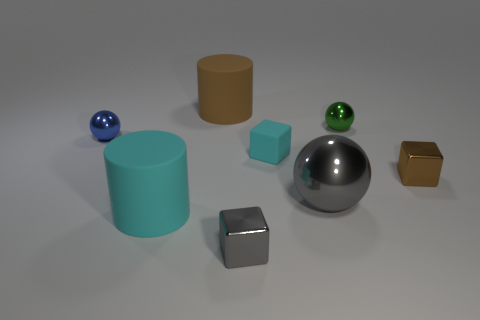Subtract all tiny metallic spheres. How many spheres are left? 1 Add 1 tiny green cubes. How many objects exist? 9 Subtract 1 balls. How many balls are left? 2 Subtract all cubes. How many objects are left? 5 Add 3 small blue objects. How many small blue objects exist? 4 Subtract 1 cyan cylinders. How many objects are left? 7 Subtract all blue cubes. Subtract all red balls. How many cubes are left? 3 Subtract all purple balls. Subtract all big matte cylinders. How many objects are left? 6 Add 6 cyan rubber objects. How many cyan rubber objects are left? 8 